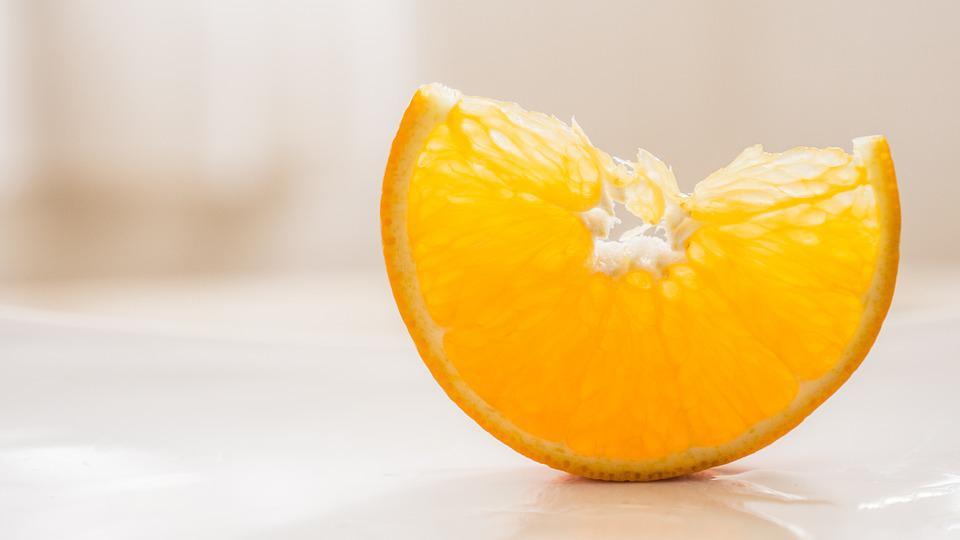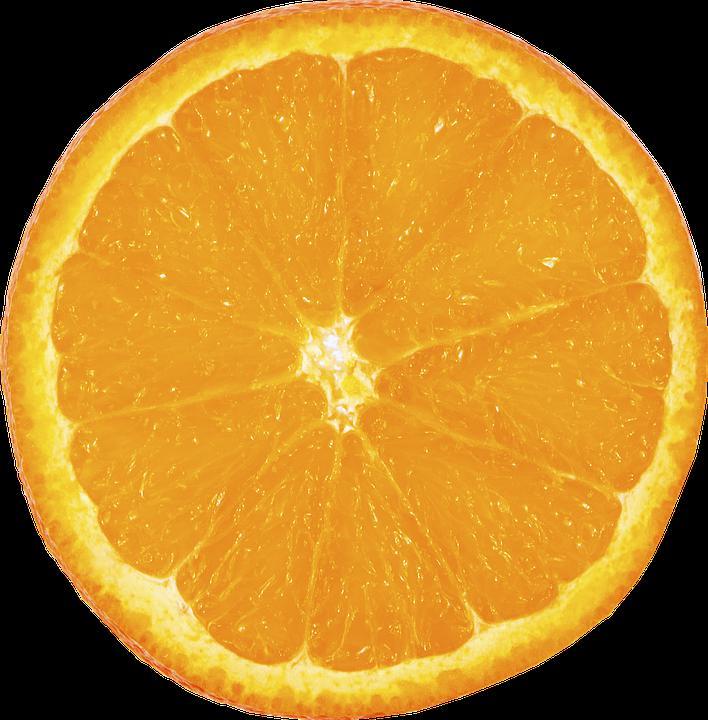The first image is the image on the left, the second image is the image on the right. Considering the images on both sides, is "There is one whole uncut orange in the left image." valid? Answer yes or no. No. 